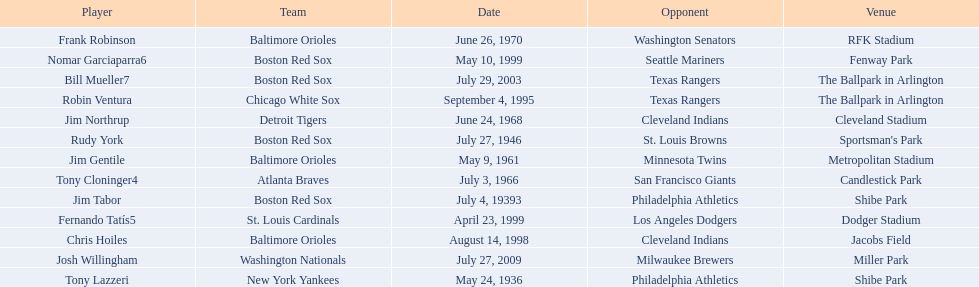Which teams played between the years 1960 and 1970? Baltimore Orioles, Atlanta Braves, Detroit Tigers, Baltimore Orioles. Of these teams that played, which ones played against the cleveland indians? Detroit Tigers. On what day did these two teams play? June 24, 1968. 